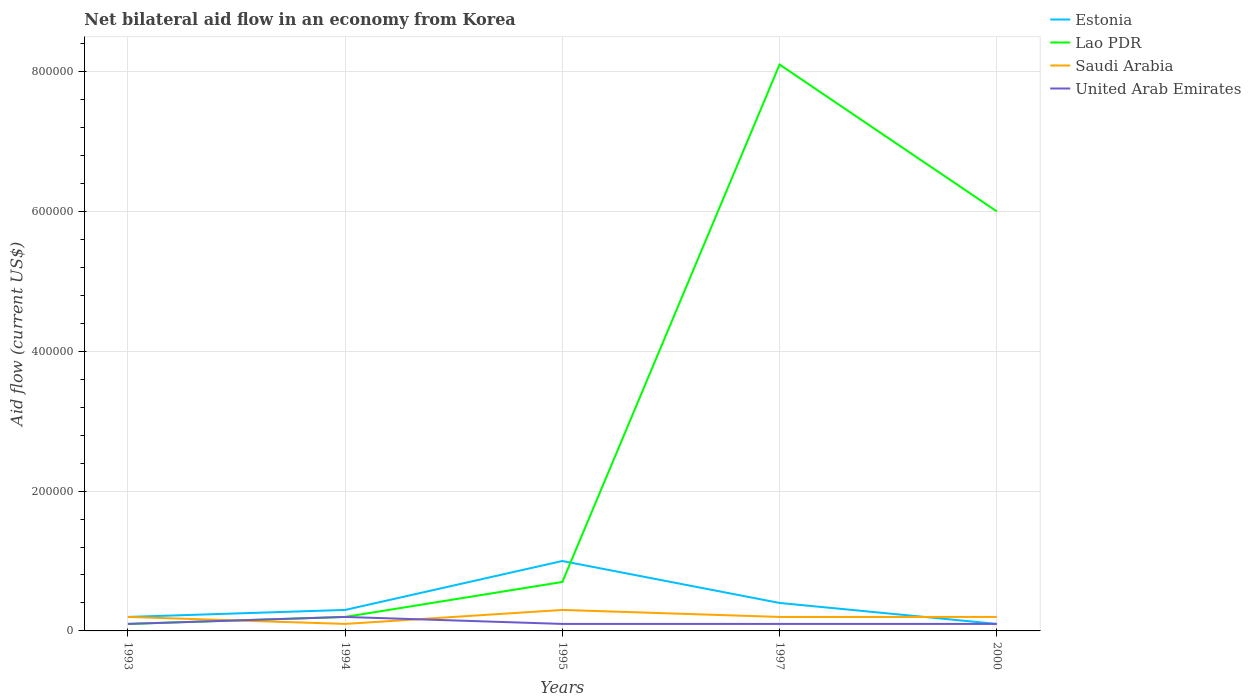Does the line corresponding to United Arab Emirates intersect with the line corresponding to Estonia?
Offer a very short reply. Yes. Across all years, what is the maximum net bilateral aid flow in United Arab Emirates?
Offer a very short reply. 10000. In which year was the net bilateral aid flow in Estonia maximum?
Keep it short and to the point. 2000. What is the total net bilateral aid flow in Lao PDR in the graph?
Your answer should be compact. -5.30e+05. What is the difference between the highest and the second highest net bilateral aid flow in Lao PDR?
Make the answer very short. 8.00e+05. Is the net bilateral aid flow in Estonia strictly greater than the net bilateral aid flow in Lao PDR over the years?
Offer a very short reply. No. How many lines are there?
Ensure brevity in your answer.  4. What is the difference between two consecutive major ticks on the Y-axis?
Provide a short and direct response. 2.00e+05. Does the graph contain any zero values?
Ensure brevity in your answer.  No. Does the graph contain grids?
Ensure brevity in your answer.  Yes. Where does the legend appear in the graph?
Your response must be concise. Top right. How many legend labels are there?
Offer a very short reply. 4. How are the legend labels stacked?
Keep it short and to the point. Vertical. What is the title of the graph?
Give a very brief answer. Net bilateral aid flow in an economy from Korea. Does "Chad" appear as one of the legend labels in the graph?
Offer a terse response. No. What is the label or title of the Y-axis?
Your answer should be compact. Aid flow (current US$). What is the Aid flow (current US$) of Saudi Arabia in 1993?
Your response must be concise. 2.00e+04. What is the Aid flow (current US$) in United Arab Emirates in 1993?
Ensure brevity in your answer.  10000. What is the Aid flow (current US$) of Estonia in 1994?
Give a very brief answer. 3.00e+04. What is the Aid flow (current US$) in Lao PDR in 1994?
Give a very brief answer. 2.00e+04. What is the Aid flow (current US$) in Saudi Arabia in 1994?
Give a very brief answer. 10000. What is the Aid flow (current US$) of Saudi Arabia in 1995?
Ensure brevity in your answer.  3.00e+04. What is the Aid flow (current US$) of United Arab Emirates in 1995?
Make the answer very short. 10000. What is the Aid flow (current US$) in Lao PDR in 1997?
Ensure brevity in your answer.  8.10e+05. What is the Aid flow (current US$) of Saudi Arabia in 1997?
Your answer should be compact. 2.00e+04. What is the Aid flow (current US$) in Estonia in 2000?
Ensure brevity in your answer.  10000. What is the Aid flow (current US$) of Lao PDR in 2000?
Ensure brevity in your answer.  6.00e+05. What is the Aid flow (current US$) in Saudi Arabia in 2000?
Your answer should be very brief. 2.00e+04. Across all years, what is the maximum Aid flow (current US$) of Lao PDR?
Make the answer very short. 8.10e+05. Across all years, what is the minimum Aid flow (current US$) of Saudi Arabia?
Your answer should be very brief. 10000. Across all years, what is the minimum Aid flow (current US$) of United Arab Emirates?
Your answer should be very brief. 10000. What is the total Aid flow (current US$) of Lao PDR in the graph?
Your answer should be compact. 1.51e+06. What is the difference between the Aid flow (current US$) of Saudi Arabia in 1993 and that in 1994?
Your answer should be compact. 10000. What is the difference between the Aid flow (current US$) in Estonia in 1993 and that in 1995?
Provide a short and direct response. -8.00e+04. What is the difference between the Aid flow (current US$) of Saudi Arabia in 1993 and that in 1995?
Your answer should be compact. -10000. What is the difference between the Aid flow (current US$) in United Arab Emirates in 1993 and that in 1995?
Your answer should be compact. 0. What is the difference between the Aid flow (current US$) in Estonia in 1993 and that in 1997?
Offer a very short reply. -2.00e+04. What is the difference between the Aid flow (current US$) of Lao PDR in 1993 and that in 1997?
Your answer should be compact. -8.00e+05. What is the difference between the Aid flow (current US$) of Saudi Arabia in 1993 and that in 1997?
Make the answer very short. 0. What is the difference between the Aid flow (current US$) of United Arab Emirates in 1993 and that in 1997?
Make the answer very short. 0. What is the difference between the Aid flow (current US$) in Estonia in 1993 and that in 2000?
Your response must be concise. 10000. What is the difference between the Aid flow (current US$) in Lao PDR in 1993 and that in 2000?
Make the answer very short. -5.90e+05. What is the difference between the Aid flow (current US$) of Saudi Arabia in 1993 and that in 2000?
Offer a very short reply. 0. What is the difference between the Aid flow (current US$) of United Arab Emirates in 1993 and that in 2000?
Provide a succinct answer. 0. What is the difference between the Aid flow (current US$) in United Arab Emirates in 1994 and that in 1995?
Your answer should be compact. 10000. What is the difference between the Aid flow (current US$) in Lao PDR in 1994 and that in 1997?
Your answer should be very brief. -7.90e+05. What is the difference between the Aid flow (current US$) of Saudi Arabia in 1994 and that in 1997?
Provide a succinct answer. -10000. What is the difference between the Aid flow (current US$) in Estonia in 1994 and that in 2000?
Provide a succinct answer. 2.00e+04. What is the difference between the Aid flow (current US$) of Lao PDR in 1994 and that in 2000?
Ensure brevity in your answer.  -5.80e+05. What is the difference between the Aid flow (current US$) in Saudi Arabia in 1994 and that in 2000?
Make the answer very short. -10000. What is the difference between the Aid flow (current US$) in Estonia in 1995 and that in 1997?
Your answer should be very brief. 6.00e+04. What is the difference between the Aid flow (current US$) of Lao PDR in 1995 and that in 1997?
Your answer should be compact. -7.40e+05. What is the difference between the Aid flow (current US$) of United Arab Emirates in 1995 and that in 1997?
Provide a succinct answer. 0. What is the difference between the Aid flow (current US$) in Lao PDR in 1995 and that in 2000?
Provide a succinct answer. -5.30e+05. What is the difference between the Aid flow (current US$) in Saudi Arabia in 1995 and that in 2000?
Ensure brevity in your answer.  10000. What is the difference between the Aid flow (current US$) of Estonia in 1997 and that in 2000?
Provide a short and direct response. 3.00e+04. What is the difference between the Aid flow (current US$) in Lao PDR in 1997 and that in 2000?
Make the answer very short. 2.10e+05. What is the difference between the Aid flow (current US$) of Saudi Arabia in 1997 and that in 2000?
Provide a short and direct response. 0. What is the difference between the Aid flow (current US$) in Estonia in 1993 and the Aid flow (current US$) in Saudi Arabia in 1994?
Offer a terse response. 10000. What is the difference between the Aid flow (current US$) in Lao PDR in 1993 and the Aid flow (current US$) in United Arab Emirates in 1994?
Offer a very short reply. -10000. What is the difference between the Aid flow (current US$) in Estonia in 1993 and the Aid flow (current US$) in Lao PDR in 1995?
Your answer should be compact. -5.00e+04. What is the difference between the Aid flow (current US$) in Lao PDR in 1993 and the Aid flow (current US$) in United Arab Emirates in 1995?
Make the answer very short. 0. What is the difference between the Aid flow (current US$) of Saudi Arabia in 1993 and the Aid flow (current US$) of United Arab Emirates in 1995?
Your response must be concise. 10000. What is the difference between the Aid flow (current US$) of Estonia in 1993 and the Aid flow (current US$) of Lao PDR in 1997?
Give a very brief answer. -7.90e+05. What is the difference between the Aid flow (current US$) in Estonia in 1993 and the Aid flow (current US$) in Saudi Arabia in 1997?
Your answer should be very brief. 0. What is the difference between the Aid flow (current US$) of Saudi Arabia in 1993 and the Aid flow (current US$) of United Arab Emirates in 1997?
Ensure brevity in your answer.  10000. What is the difference between the Aid flow (current US$) of Estonia in 1993 and the Aid flow (current US$) of Lao PDR in 2000?
Your response must be concise. -5.80e+05. What is the difference between the Aid flow (current US$) of Estonia in 1993 and the Aid flow (current US$) of Saudi Arabia in 2000?
Your answer should be very brief. 0. What is the difference between the Aid flow (current US$) of Lao PDR in 1993 and the Aid flow (current US$) of Saudi Arabia in 2000?
Your response must be concise. -10000. What is the difference between the Aid flow (current US$) in Saudi Arabia in 1993 and the Aid flow (current US$) in United Arab Emirates in 2000?
Give a very brief answer. 10000. What is the difference between the Aid flow (current US$) in Estonia in 1994 and the Aid flow (current US$) in Saudi Arabia in 1995?
Your answer should be very brief. 0. What is the difference between the Aid flow (current US$) of Estonia in 1994 and the Aid flow (current US$) of Lao PDR in 1997?
Give a very brief answer. -7.80e+05. What is the difference between the Aid flow (current US$) of Estonia in 1994 and the Aid flow (current US$) of United Arab Emirates in 1997?
Keep it short and to the point. 2.00e+04. What is the difference between the Aid flow (current US$) in Lao PDR in 1994 and the Aid flow (current US$) in Saudi Arabia in 1997?
Offer a terse response. 0. What is the difference between the Aid flow (current US$) in Lao PDR in 1994 and the Aid flow (current US$) in United Arab Emirates in 1997?
Your response must be concise. 10000. What is the difference between the Aid flow (current US$) of Saudi Arabia in 1994 and the Aid flow (current US$) of United Arab Emirates in 1997?
Keep it short and to the point. 0. What is the difference between the Aid flow (current US$) in Estonia in 1994 and the Aid flow (current US$) in Lao PDR in 2000?
Your answer should be compact. -5.70e+05. What is the difference between the Aid flow (current US$) of Estonia in 1994 and the Aid flow (current US$) of United Arab Emirates in 2000?
Provide a short and direct response. 2.00e+04. What is the difference between the Aid flow (current US$) in Estonia in 1995 and the Aid flow (current US$) in Lao PDR in 1997?
Provide a short and direct response. -7.10e+05. What is the difference between the Aid flow (current US$) of Estonia in 1995 and the Aid flow (current US$) of United Arab Emirates in 1997?
Make the answer very short. 9.00e+04. What is the difference between the Aid flow (current US$) of Lao PDR in 1995 and the Aid flow (current US$) of Saudi Arabia in 1997?
Ensure brevity in your answer.  5.00e+04. What is the difference between the Aid flow (current US$) of Lao PDR in 1995 and the Aid flow (current US$) of United Arab Emirates in 1997?
Offer a very short reply. 6.00e+04. What is the difference between the Aid flow (current US$) in Estonia in 1995 and the Aid flow (current US$) in Lao PDR in 2000?
Your response must be concise. -5.00e+05. What is the difference between the Aid flow (current US$) of Lao PDR in 1995 and the Aid flow (current US$) of Saudi Arabia in 2000?
Give a very brief answer. 5.00e+04. What is the difference between the Aid flow (current US$) in Lao PDR in 1995 and the Aid flow (current US$) in United Arab Emirates in 2000?
Your answer should be compact. 6.00e+04. What is the difference between the Aid flow (current US$) of Saudi Arabia in 1995 and the Aid flow (current US$) of United Arab Emirates in 2000?
Offer a terse response. 2.00e+04. What is the difference between the Aid flow (current US$) in Estonia in 1997 and the Aid flow (current US$) in Lao PDR in 2000?
Your answer should be compact. -5.60e+05. What is the difference between the Aid flow (current US$) in Estonia in 1997 and the Aid flow (current US$) in United Arab Emirates in 2000?
Provide a short and direct response. 3.00e+04. What is the difference between the Aid flow (current US$) of Lao PDR in 1997 and the Aid flow (current US$) of Saudi Arabia in 2000?
Provide a succinct answer. 7.90e+05. What is the difference between the Aid flow (current US$) in Lao PDR in 1997 and the Aid flow (current US$) in United Arab Emirates in 2000?
Your answer should be very brief. 8.00e+05. What is the average Aid flow (current US$) in Estonia per year?
Provide a succinct answer. 4.00e+04. What is the average Aid flow (current US$) in Lao PDR per year?
Your answer should be compact. 3.02e+05. What is the average Aid flow (current US$) of United Arab Emirates per year?
Ensure brevity in your answer.  1.20e+04. In the year 1993, what is the difference between the Aid flow (current US$) in Lao PDR and Aid flow (current US$) in United Arab Emirates?
Provide a short and direct response. 0. In the year 1993, what is the difference between the Aid flow (current US$) of Saudi Arabia and Aid flow (current US$) of United Arab Emirates?
Provide a short and direct response. 10000. In the year 1994, what is the difference between the Aid flow (current US$) in Estonia and Aid flow (current US$) in Lao PDR?
Offer a very short reply. 10000. In the year 1994, what is the difference between the Aid flow (current US$) of Estonia and Aid flow (current US$) of United Arab Emirates?
Make the answer very short. 10000. In the year 1994, what is the difference between the Aid flow (current US$) in Saudi Arabia and Aid flow (current US$) in United Arab Emirates?
Keep it short and to the point. -10000. In the year 1995, what is the difference between the Aid flow (current US$) in Estonia and Aid flow (current US$) in United Arab Emirates?
Make the answer very short. 9.00e+04. In the year 1995, what is the difference between the Aid flow (current US$) of Lao PDR and Aid flow (current US$) of Saudi Arabia?
Your answer should be compact. 4.00e+04. In the year 1995, what is the difference between the Aid flow (current US$) in Lao PDR and Aid flow (current US$) in United Arab Emirates?
Your answer should be compact. 6.00e+04. In the year 1997, what is the difference between the Aid flow (current US$) in Estonia and Aid flow (current US$) in Lao PDR?
Make the answer very short. -7.70e+05. In the year 1997, what is the difference between the Aid flow (current US$) of Estonia and Aid flow (current US$) of Saudi Arabia?
Your answer should be compact. 2.00e+04. In the year 1997, what is the difference between the Aid flow (current US$) of Lao PDR and Aid flow (current US$) of Saudi Arabia?
Offer a very short reply. 7.90e+05. In the year 1997, what is the difference between the Aid flow (current US$) in Lao PDR and Aid flow (current US$) in United Arab Emirates?
Give a very brief answer. 8.00e+05. In the year 1997, what is the difference between the Aid flow (current US$) of Saudi Arabia and Aid flow (current US$) of United Arab Emirates?
Keep it short and to the point. 10000. In the year 2000, what is the difference between the Aid flow (current US$) of Estonia and Aid flow (current US$) of Lao PDR?
Offer a very short reply. -5.90e+05. In the year 2000, what is the difference between the Aid flow (current US$) of Lao PDR and Aid flow (current US$) of Saudi Arabia?
Your answer should be compact. 5.80e+05. In the year 2000, what is the difference between the Aid flow (current US$) of Lao PDR and Aid flow (current US$) of United Arab Emirates?
Your answer should be very brief. 5.90e+05. In the year 2000, what is the difference between the Aid flow (current US$) of Saudi Arabia and Aid flow (current US$) of United Arab Emirates?
Offer a terse response. 10000. What is the ratio of the Aid flow (current US$) of Estonia in 1993 to that in 1994?
Make the answer very short. 0.67. What is the ratio of the Aid flow (current US$) in Lao PDR in 1993 to that in 1994?
Offer a very short reply. 0.5. What is the ratio of the Aid flow (current US$) in Estonia in 1993 to that in 1995?
Offer a very short reply. 0.2. What is the ratio of the Aid flow (current US$) in Lao PDR in 1993 to that in 1995?
Keep it short and to the point. 0.14. What is the ratio of the Aid flow (current US$) in United Arab Emirates in 1993 to that in 1995?
Your response must be concise. 1. What is the ratio of the Aid flow (current US$) in Lao PDR in 1993 to that in 1997?
Give a very brief answer. 0.01. What is the ratio of the Aid flow (current US$) in Lao PDR in 1993 to that in 2000?
Provide a succinct answer. 0.02. What is the ratio of the Aid flow (current US$) of United Arab Emirates in 1993 to that in 2000?
Give a very brief answer. 1. What is the ratio of the Aid flow (current US$) in Estonia in 1994 to that in 1995?
Provide a succinct answer. 0.3. What is the ratio of the Aid flow (current US$) in Lao PDR in 1994 to that in 1995?
Your answer should be very brief. 0.29. What is the ratio of the Aid flow (current US$) in United Arab Emirates in 1994 to that in 1995?
Provide a succinct answer. 2. What is the ratio of the Aid flow (current US$) of Lao PDR in 1994 to that in 1997?
Give a very brief answer. 0.02. What is the ratio of the Aid flow (current US$) in Saudi Arabia in 1994 to that in 1997?
Your answer should be compact. 0.5. What is the ratio of the Aid flow (current US$) in Saudi Arabia in 1994 to that in 2000?
Your answer should be very brief. 0.5. What is the ratio of the Aid flow (current US$) of United Arab Emirates in 1994 to that in 2000?
Keep it short and to the point. 2. What is the ratio of the Aid flow (current US$) in Estonia in 1995 to that in 1997?
Keep it short and to the point. 2.5. What is the ratio of the Aid flow (current US$) in Lao PDR in 1995 to that in 1997?
Ensure brevity in your answer.  0.09. What is the ratio of the Aid flow (current US$) of Saudi Arabia in 1995 to that in 1997?
Ensure brevity in your answer.  1.5. What is the ratio of the Aid flow (current US$) of United Arab Emirates in 1995 to that in 1997?
Ensure brevity in your answer.  1. What is the ratio of the Aid flow (current US$) of Lao PDR in 1995 to that in 2000?
Your answer should be compact. 0.12. What is the ratio of the Aid flow (current US$) in Saudi Arabia in 1995 to that in 2000?
Make the answer very short. 1.5. What is the ratio of the Aid flow (current US$) in Lao PDR in 1997 to that in 2000?
Provide a short and direct response. 1.35. What is the ratio of the Aid flow (current US$) in United Arab Emirates in 1997 to that in 2000?
Provide a short and direct response. 1. What is the difference between the highest and the second highest Aid flow (current US$) of Estonia?
Your answer should be compact. 6.00e+04. What is the difference between the highest and the second highest Aid flow (current US$) in Lao PDR?
Provide a short and direct response. 2.10e+05. What is the difference between the highest and the lowest Aid flow (current US$) of Estonia?
Ensure brevity in your answer.  9.00e+04. What is the difference between the highest and the lowest Aid flow (current US$) of Lao PDR?
Ensure brevity in your answer.  8.00e+05. What is the difference between the highest and the lowest Aid flow (current US$) in Saudi Arabia?
Give a very brief answer. 2.00e+04. 